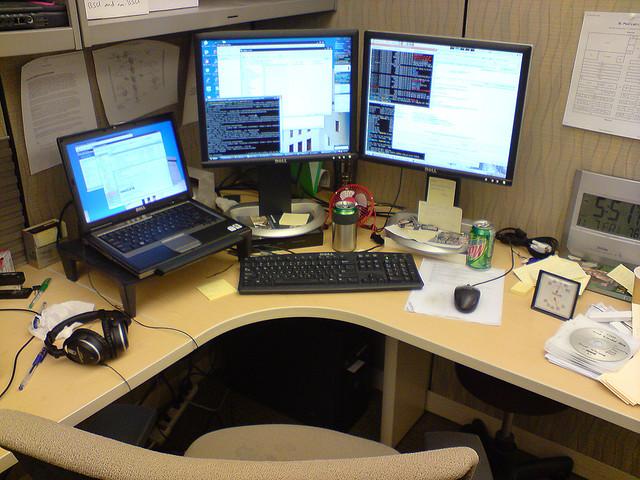Can a person listen to music without disturbing others if need be?
Keep it brief. Yes. How many keyboards are visible?
Answer briefly. 2. Is there a chair in the office?
Quick response, please. Yes. What color are the soda cans?
Concise answer only. Green. 